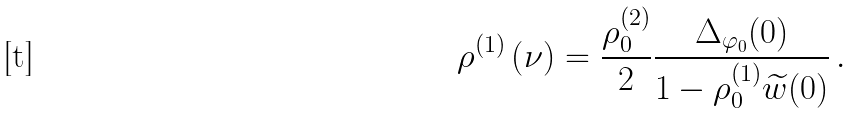<formula> <loc_0><loc_0><loc_500><loc_500>\rho ^ { ( 1 ) } \left ( \nu \right ) = \frac { \rho _ { 0 } ^ { ( 2 ) } } { 2 } \frac { \Delta _ { \varphi _ { 0 } } ( 0 ) } { 1 - \rho _ { 0 } ^ { ( 1 ) } \widetilde { w } ( 0 ) } \, .</formula> 